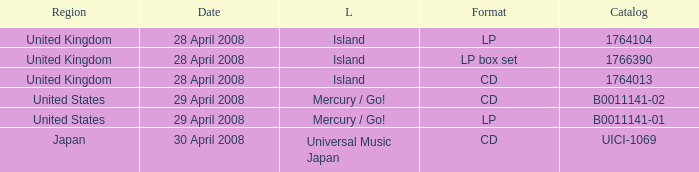What is the Label of the UICI-1069 Catalog? Universal Music Japan. 